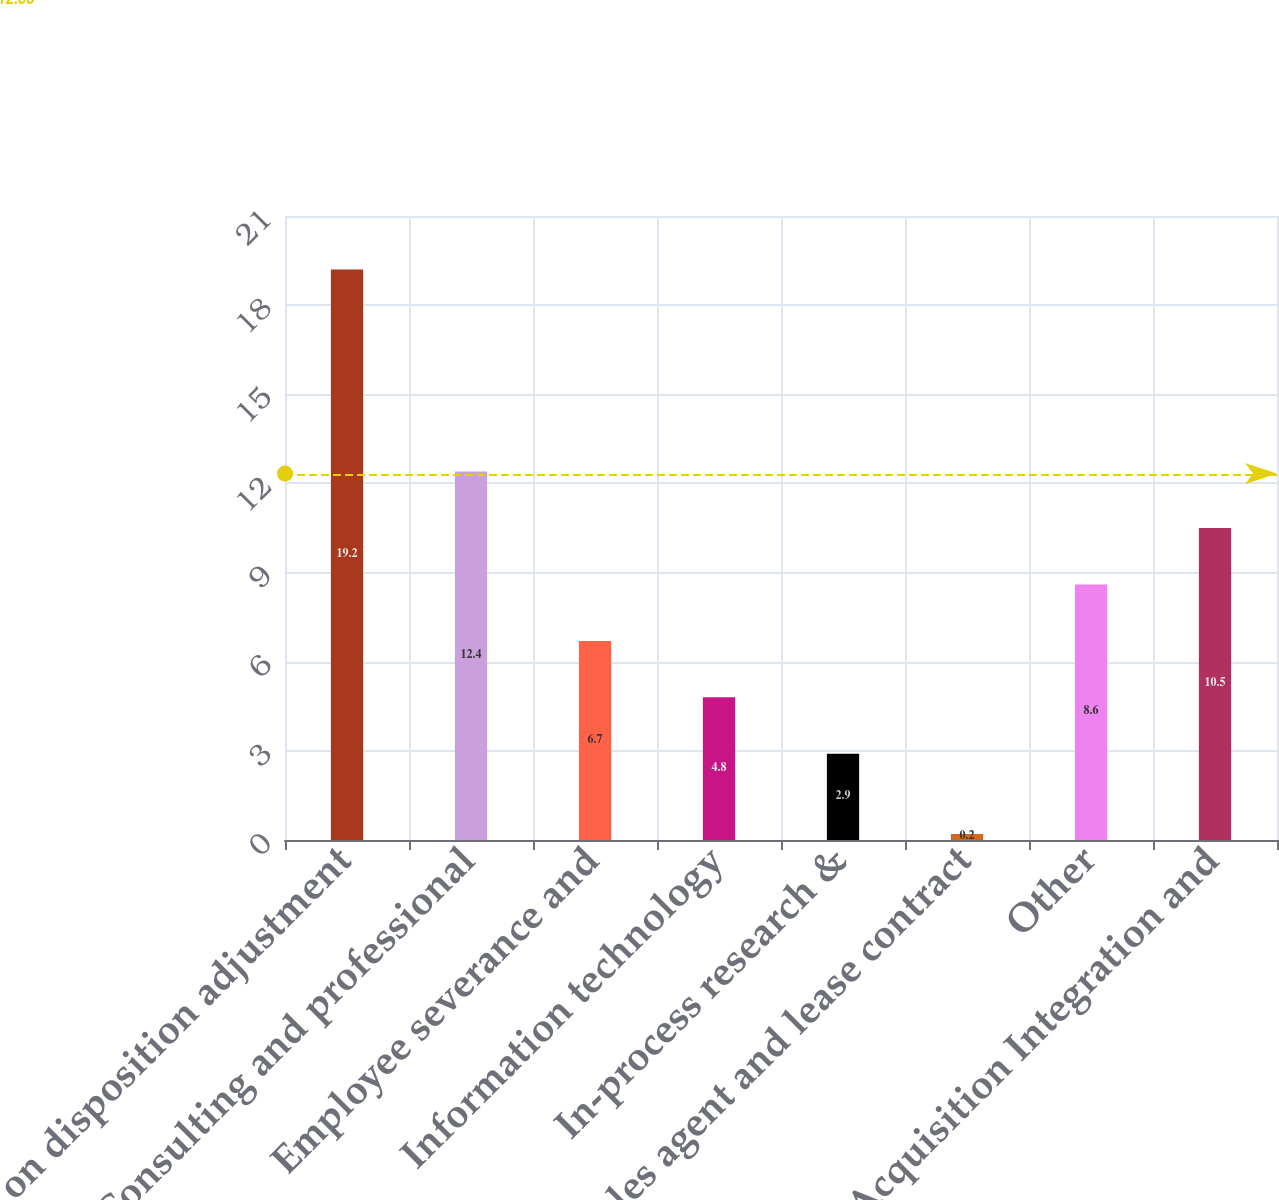Convert chart. <chart><loc_0><loc_0><loc_500><loc_500><bar_chart><fcel>Gain on disposition adjustment<fcel>Consulting and professional<fcel>Employee severance and<fcel>Information technology<fcel>In-process research &<fcel>Sales agent and lease contract<fcel>Other<fcel>Acquisition Integration and<nl><fcel>19.2<fcel>12.4<fcel>6.7<fcel>4.8<fcel>2.9<fcel>0.2<fcel>8.6<fcel>10.5<nl></chart> 